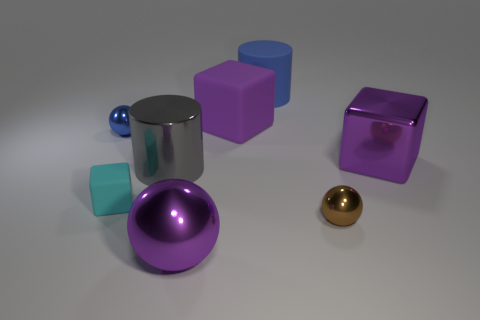Add 1 small purple rubber things. How many objects exist? 9 Subtract all cubes. How many objects are left? 5 Subtract all big yellow things. Subtract all small blue metal objects. How many objects are left? 7 Add 7 tiny brown metallic things. How many tiny brown metallic things are left? 8 Add 2 blue shiny balls. How many blue shiny balls exist? 3 Subtract 0 blue cubes. How many objects are left? 8 